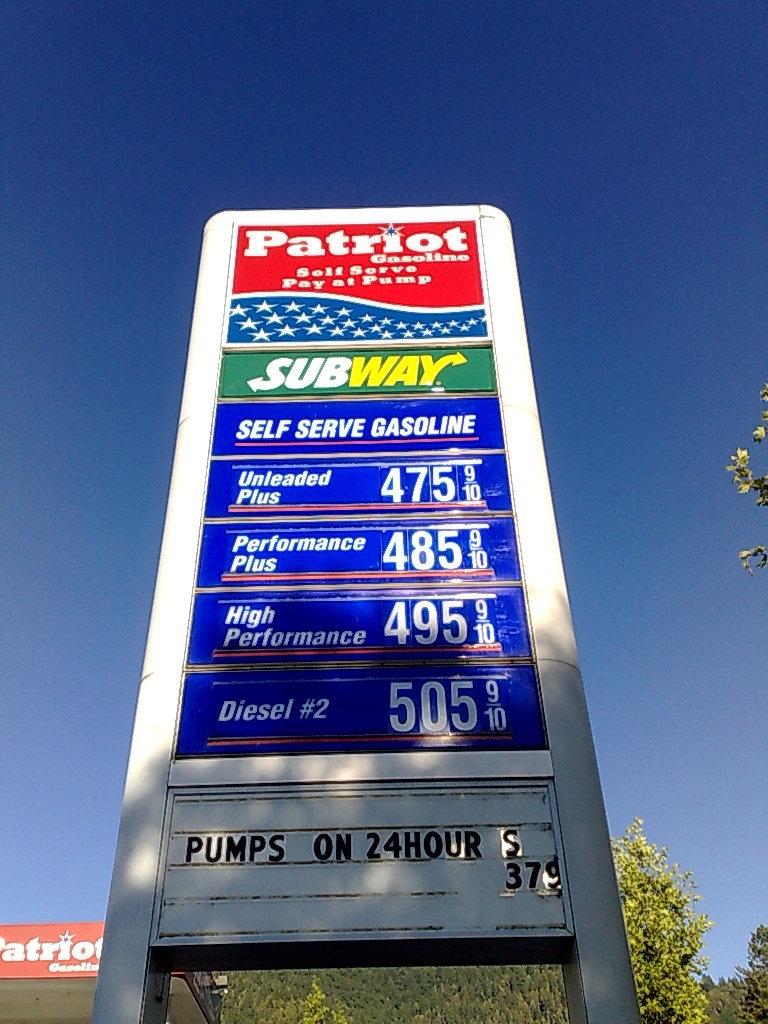Which sandwich chain do they have inside this gas station?
Ensure brevity in your answer.  Subway. 